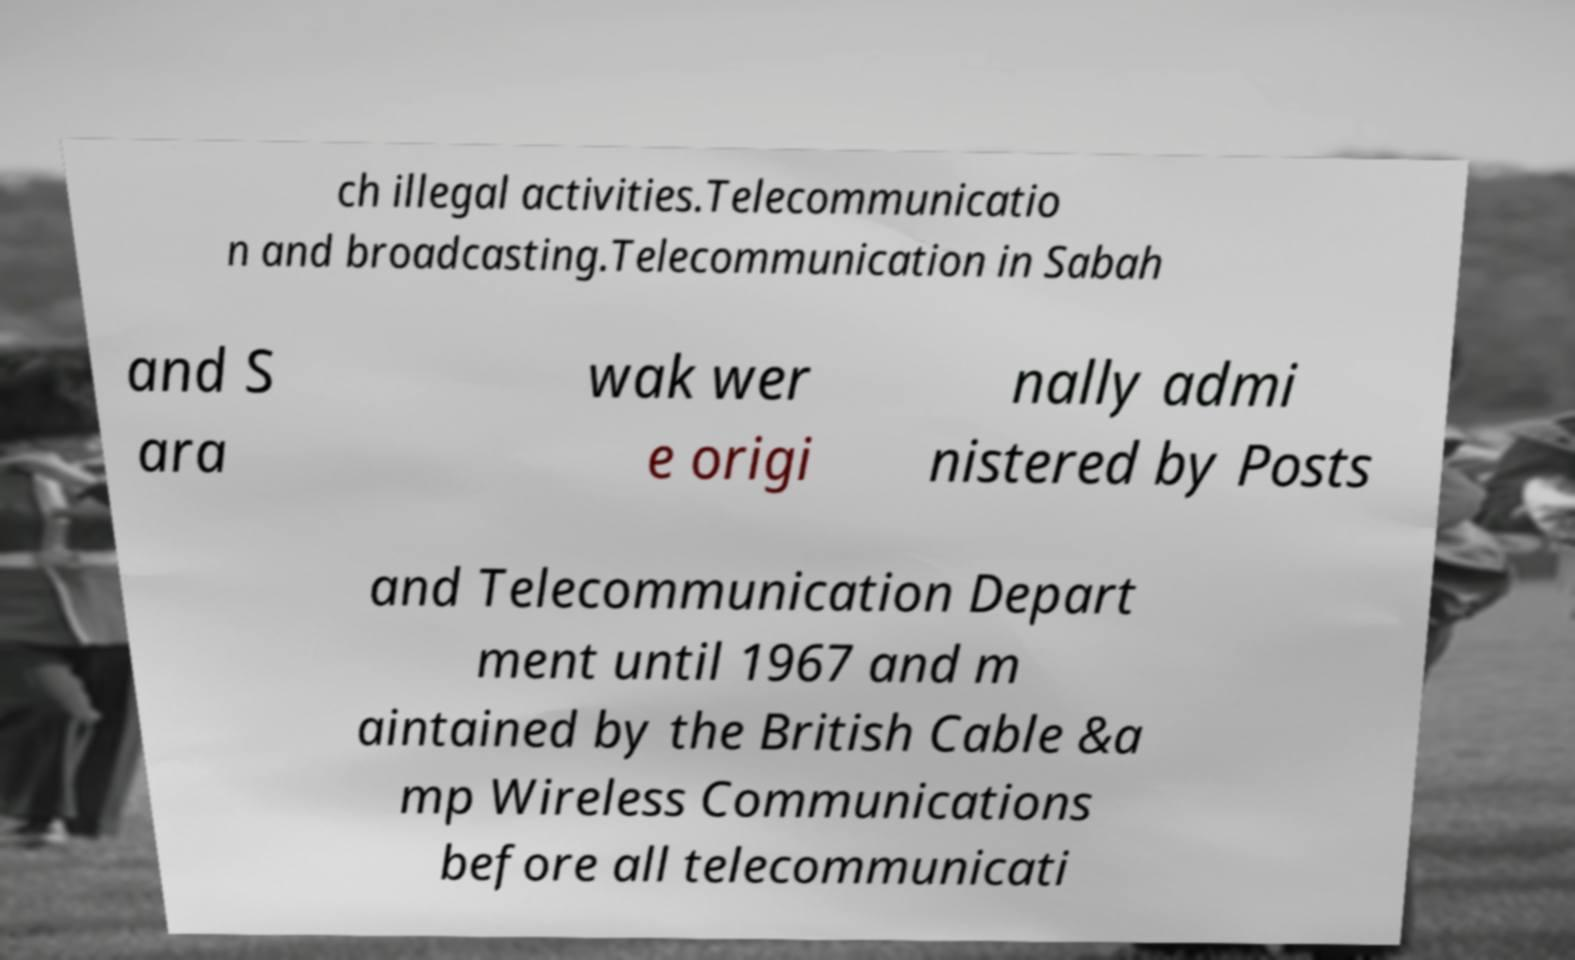Could you extract and type out the text from this image? ch illegal activities.Telecommunicatio n and broadcasting.Telecommunication in Sabah and S ara wak wer e origi nally admi nistered by Posts and Telecommunication Depart ment until 1967 and m aintained by the British Cable &a mp Wireless Communications before all telecommunicati 